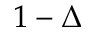Convert formula to latex. <formula><loc_0><loc_0><loc_500><loc_500>1 - \Delta</formula> 